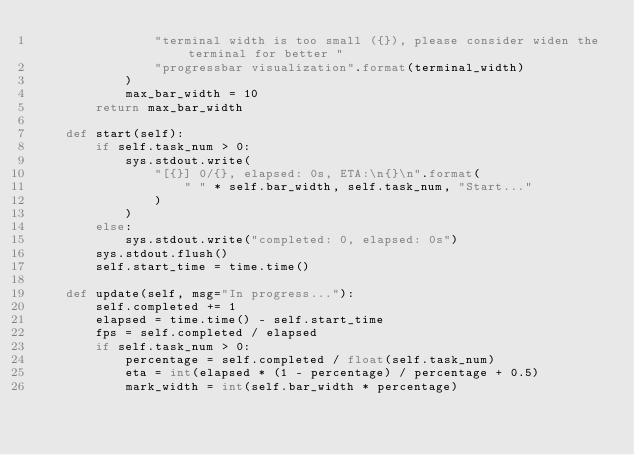Convert code to text. <code><loc_0><loc_0><loc_500><loc_500><_Python_>                "terminal width is too small ({}), please consider widen the terminal for better "
                "progressbar visualization".format(terminal_width)
            )
            max_bar_width = 10
        return max_bar_width

    def start(self):
        if self.task_num > 0:
            sys.stdout.write(
                "[{}] 0/{}, elapsed: 0s, ETA:\n{}\n".format(
                    " " * self.bar_width, self.task_num, "Start..."
                )
            )
        else:
            sys.stdout.write("completed: 0, elapsed: 0s")
        sys.stdout.flush()
        self.start_time = time.time()

    def update(self, msg="In progress..."):
        self.completed += 1
        elapsed = time.time() - self.start_time
        fps = self.completed / elapsed
        if self.task_num > 0:
            percentage = self.completed / float(self.task_num)
            eta = int(elapsed * (1 - percentage) / percentage + 0.5)
            mark_width = int(self.bar_width * percentage)</code> 